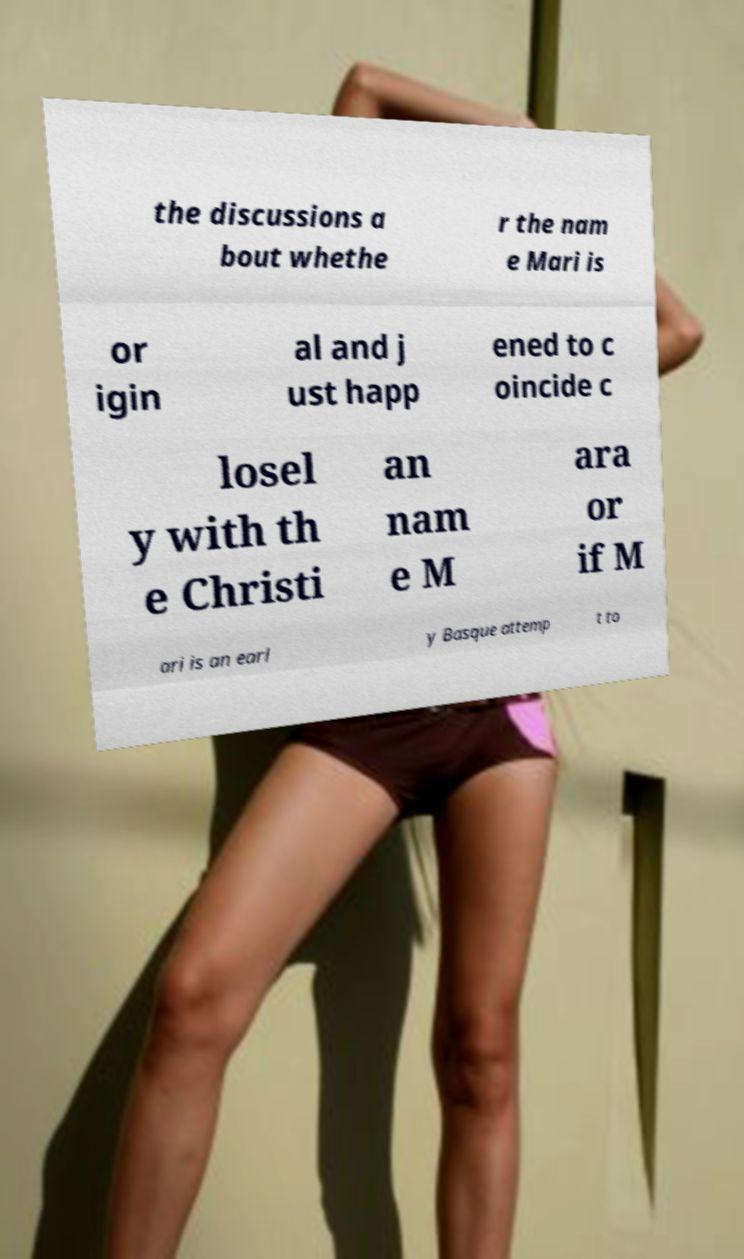For documentation purposes, I need the text within this image transcribed. Could you provide that? the discussions a bout whethe r the nam e Mari is or igin al and j ust happ ened to c oincide c losel y with th e Christi an nam e M ara or if M ari is an earl y Basque attemp t to 